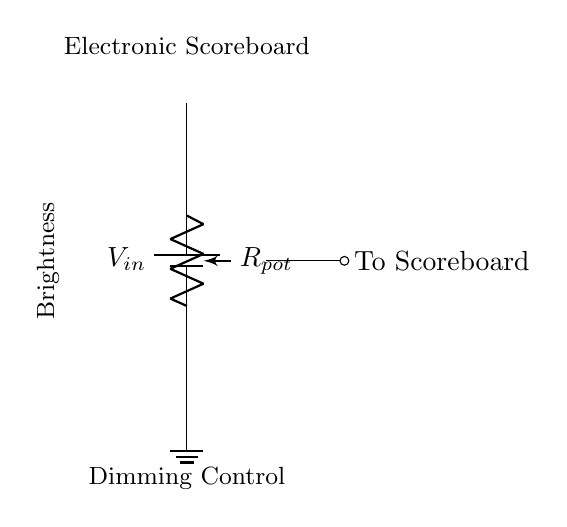What is the supply voltage in the circuit? The circuit shows a battery connected at the top, labeled V_in, which represents the input voltage supplied to the circuit. Based on standard practice in similar applications, this is typically 5V or a designated voltage; however, the exact value is not given here.
Answer: V_in What component is used to control brightness? The circuit includes a component labeled R_pot, identified as a potentiometer. Potentiometers are commonly used to adjust resistance and, in this case, control the brightness of the electronic scoreboard by varying the voltage output to it.
Answer: Potentiometer Where does the output connect? The wiper of the potentiometer, connected at the middle of the potentiometer, leads to a short connection labeled "To Scoreboard." This indicates where the adjustable voltage output is directed.
Answer: To Scoreboard What is the function of the potentiometer in this circuit? The potentiometer functions as a variable resistor, allowing the user to adjust the output voltage to the scoreboard. By changing the position of the wiper, one alters the resistance in the circuit, thereby dimming or brightening the scoreboard based on the voltage drop across the potentiometer.
Answer: Dimming How does the dimming control relate to the voltage divider concept? This circuit operates on the principle of a voltage divider, which uses the potentiometer to divide the input voltage V_in. The position of the wiper determines the division ratio and hence controls the output voltage to the scoreboard, affecting its brightness. This is characteristic of voltage divider configurations.
Answer: Voltage divider 